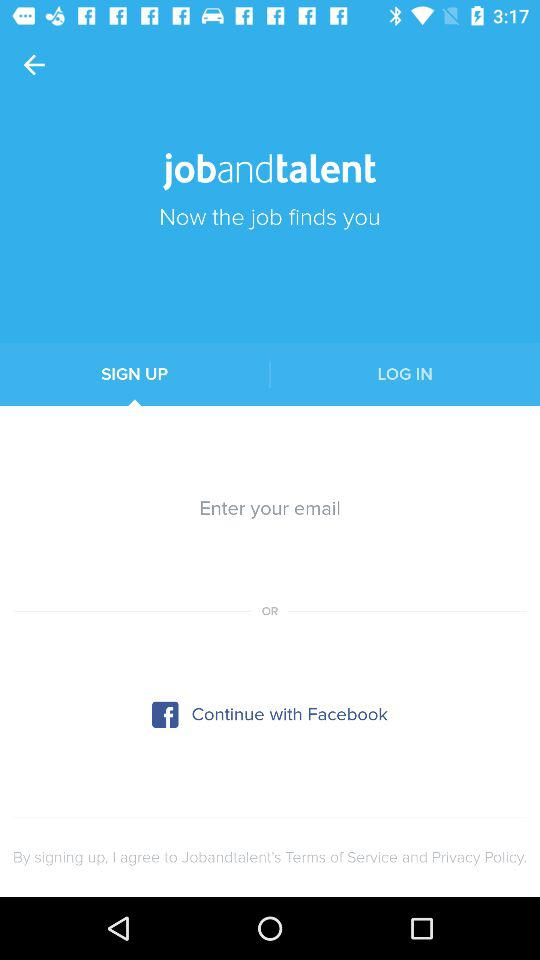What is the app name? The app name is "jobandtalent". 